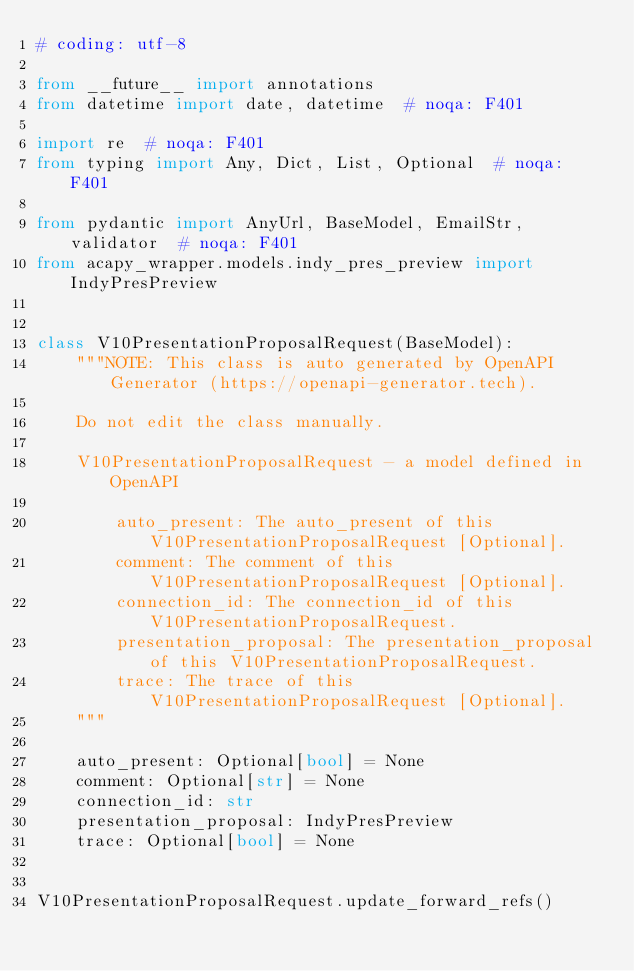<code> <loc_0><loc_0><loc_500><loc_500><_Python_># coding: utf-8

from __future__ import annotations
from datetime import date, datetime  # noqa: F401

import re  # noqa: F401
from typing import Any, Dict, List, Optional  # noqa: F401

from pydantic import AnyUrl, BaseModel, EmailStr, validator  # noqa: F401
from acapy_wrapper.models.indy_pres_preview import IndyPresPreview


class V10PresentationProposalRequest(BaseModel):
    """NOTE: This class is auto generated by OpenAPI Generator (https://openapi-generator.tech).

    Do not edit the class manually.

    V10PresentationProposalRequest - a model defined in OpenAPI

        auto_present: The auto_present of this V10PresentationProposalRequest [Optional].
        comment: The comment of this V10PresentationProposalRequest [Optional].
        connection_id: The connection_id of this V10PresentationProposalRequest.
        presentation_proposal: The presentation_proposal of this V10PresentationProposalRequest.
        trace: The trace of this V10PresentationProposalRequest [Optional].
    """

    auto_present: Optional[bool] = None
    comment: Optional[str] = None
    connection_id: str
    presentation_proposal: IndyPresPreview
    trace: Optional[bool] = None


V10PresentationProposalRequest.update_forward_refs()
</code> 